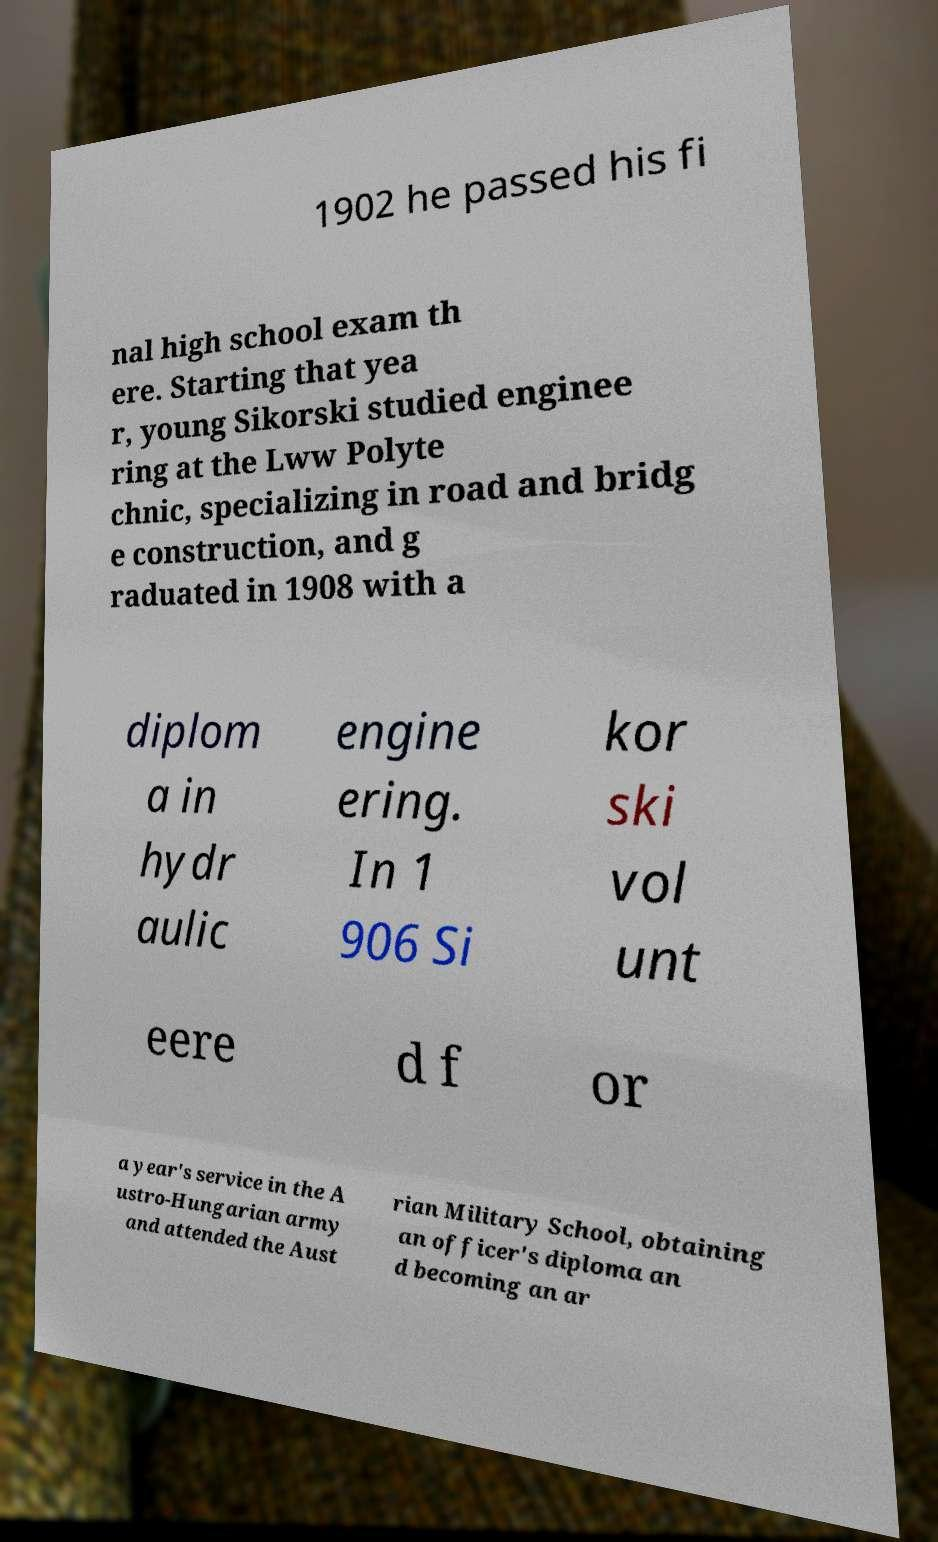I need the written content from this picture converted into text. Can you do that? 1902 he passed his fi nal high school exam th ere. Starting that yea r, young Sikorski studied enginee ring at the Lww Polyte chnic, specializing in road and bridg e construction, and g raduated in 1908 with a diplom a in hydr aulic engine ering. In 1 906 Si kor ski vol unt eere d f or a year's service in the A ustro-Hungarian army and attended the Aust rian Military School, obtaining an officer's diploma an d becoming an ar 